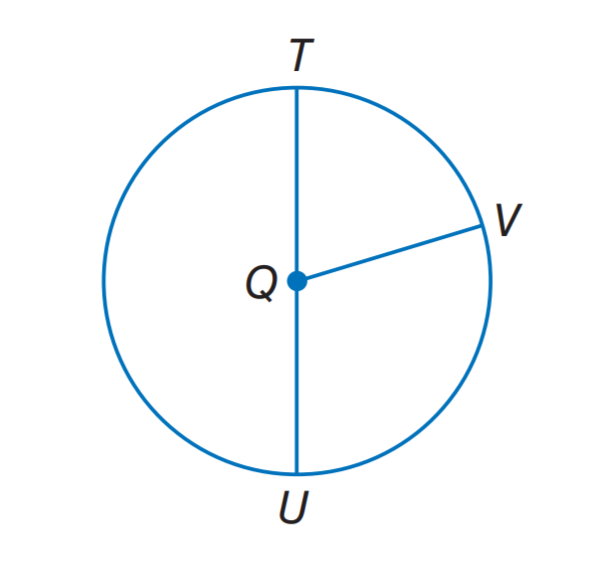Answer the mathemtical geometry problem and directly provide the correct option letter.
Question: If T U = 14, what it the radius of \odot Q.
Choices: A: 7 B: 8 C: 11 D: 16 A 